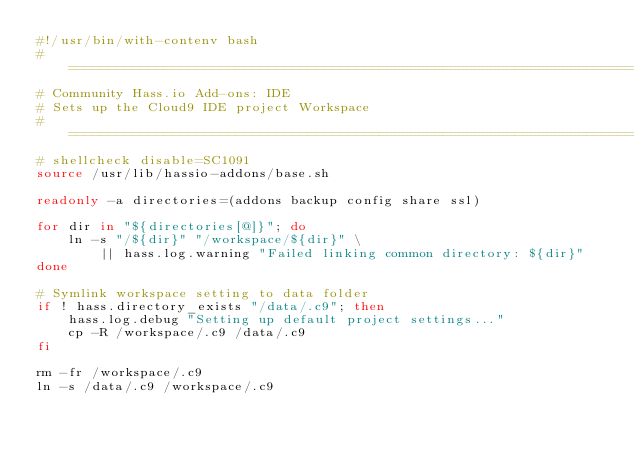<code> <loc_0><loc_0><loc_500><loc_500><_Bash_>#!/usr/bin/with-contenv bash
# ==============================================================================
# Community Hass.io Add-ons: IDE
# Sets up the Cloud9 IDE project Workspace
# ==============================================================================
# shellcheck disable=SC1091
source /usr/lib/hassio-addons/base.sh

readonly -a directories=(addons backup config share ssl)

for dir in "${directories[@]}"; do
    ln -s "/${dir}" "/workspace/${dir}" \
        || hass.log.warning "Failed linking common directory: ${dir}"
done

# Symlink workspace setting to data folder
if ! hass.directory_exists "/data/.c9"; then
    hass.log.debug "Setting up default project settings..."
    cp -R /workspace/.c9 /data/.c9
fi

rm -fr /workspace/.c9
ln -s /data/.c9 /workspace/.c9
</code> 